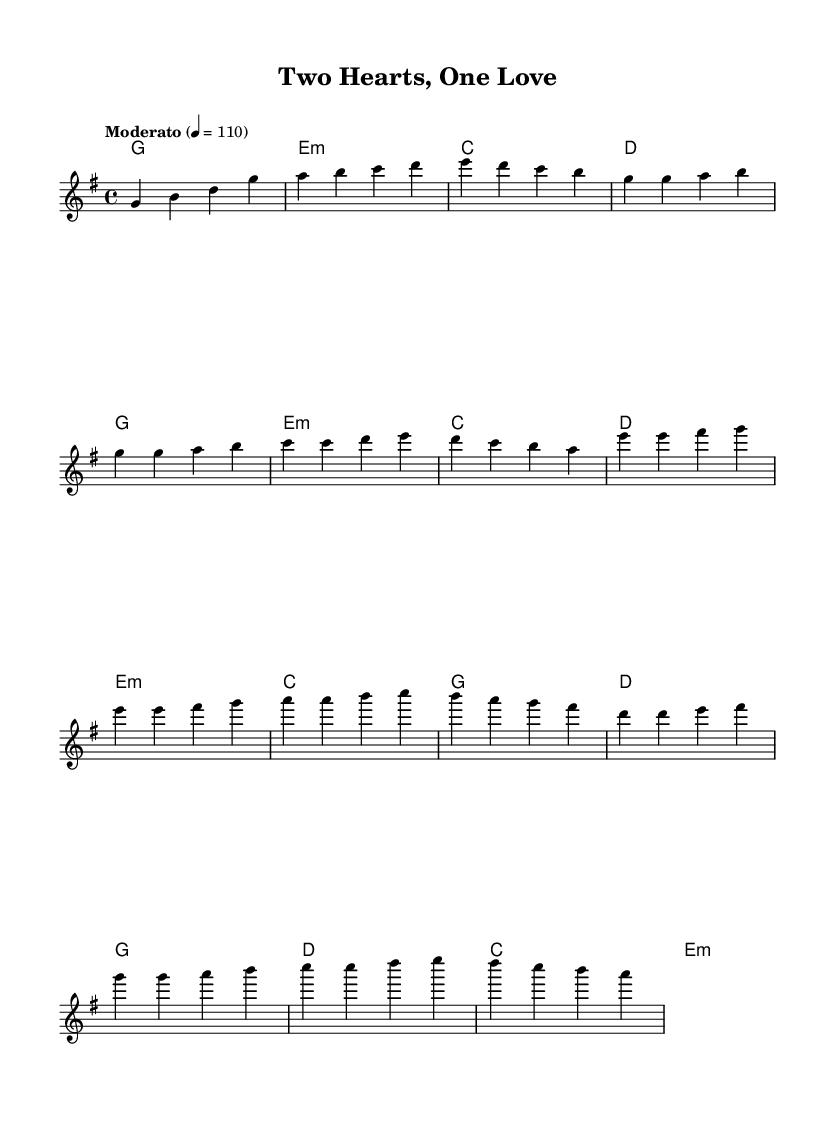What is the key signature of this music? The key signature is G major, which has one sharp (F#). This can be identified from the "key g" indication at the beginning of the staff.
Answer: G major What is the time signature of this music? The time signature is 4/4, indicated at the beginning where it shows "4/4". This means there are four beats in each measure.
Answer: 4/4 What is the tempo marking of this music? The tempo marking states "Moderato" with a metronome marking of 110. This indicates a moderate speed for the piece, and it can be found in the tempo indication section of the score.
Answer: Moderato 4 = 110 How many measures are in the chorus section? The chorus section consists of four measures. By examining the music notation, we can count the measures labeled as the chorus.
Answer: 4 Which chord is played in the pre-chorus? The chords in the pre-chorus include E minor, C, G, and D. The pre-chorus is indicated in the score by the relevant chord symbols above the melody.
Answer: E minor What is the musical structure of this piece? The structure follows a format of Intro, Verse, Pre-Chorus, and Chorus. This can be inferred from the layout of the sections as indicated in the score.
Answer: Intro, Verse, Pre-Chorus, Chorus What characteristic element of K-Pop is reflected in this song? The blending of traditional and modern musical elements is a characteristic feature of K-Pop music, seen here in the combination of harmonies and melody styles. This reflects K-Pop's unique fusion identity.
Answer: Fusion of traditional and modern elements 